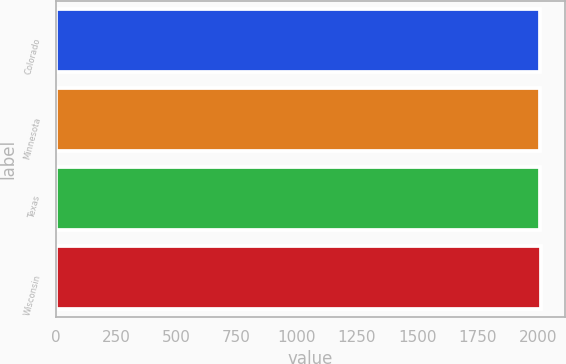<chart> <loc_0><loc_0><loc_500><loc_500><bar_chart><fcel>Colorado<fcel>Minnesota<fcel>Texas<fcel>Wisconsin<nl><fcel>2009<fcel>2009.5<fcel>2010<fcel>2014<nl></chart> 